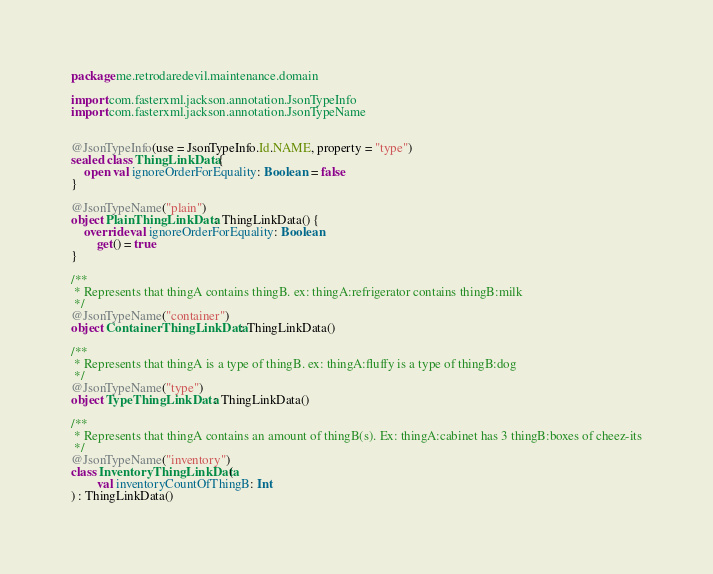<code> <loc_0><loc_0><loc_500><loc_500><_Kotlin_>package me.retrodaredevil.maintenance.domain

import com.fasterxml.jackson.annotation.JsonTypeInfo
import com.fasterxml.jackson.annotation.JsonTypeName


@JsonTypeInfo(use = JsonTypeInfo.Id.NAME, property = "type")
sealed class ThingLinkData {
    open val ignoreOrderForEquality: Boolean = false
}

@JsonTypeName("plain")
object PlainThingLinkData : ThingLinkData() {
    override val ignoreOrderForEquality: Boolean
        get() = true
}

/**
 * Represents that thingA contains thingB. ex: thingA:refrigerator contains thingB:milk
 */
@JsonTypeName("container")
object ContainerThingLinkData : ThingLinkData()

/**
 * Represents that thingA is a type of thingB. ex: thingA:fluffy is a type of thingB:dog
 */
@JsonTypeName("type")
object TypeThingLinkData : ThingLinkData()

/**
 * Represents that thingA contains an amount of thingB(s). Ex: thingA:cabinet has 3 thingB:boxes of cheez-its
 */
@JsonTypeName("inventory")
class InventoryThingLinkData(
        val inventoryCountOfThingB: Int
) : ThingLinkData()
</code> 